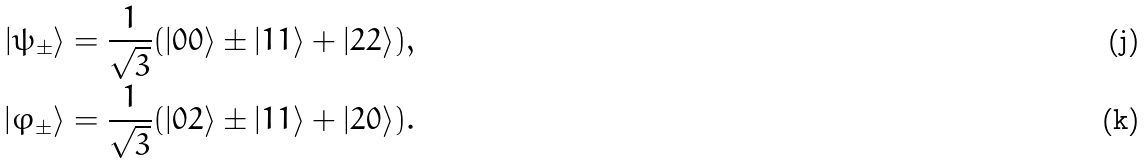Convert formula to latex. <formula><loc_0><loc_0><loc_500><loc_500>| \psi _ { \pm } \rangle = \frac { 1 } { \sqrt { 3 } } ( | 0 0 \rangle \pm | 1 1 \rangle + | 2 2 \rangle ) , \\ | \varphi _ { \pm } \rangle = \frac { 1 } { \sqrt { 3 } } ( | 0 2 \rangle \pm | 1 1 \rangle + | 2 0 \rangle ) .</formula> 